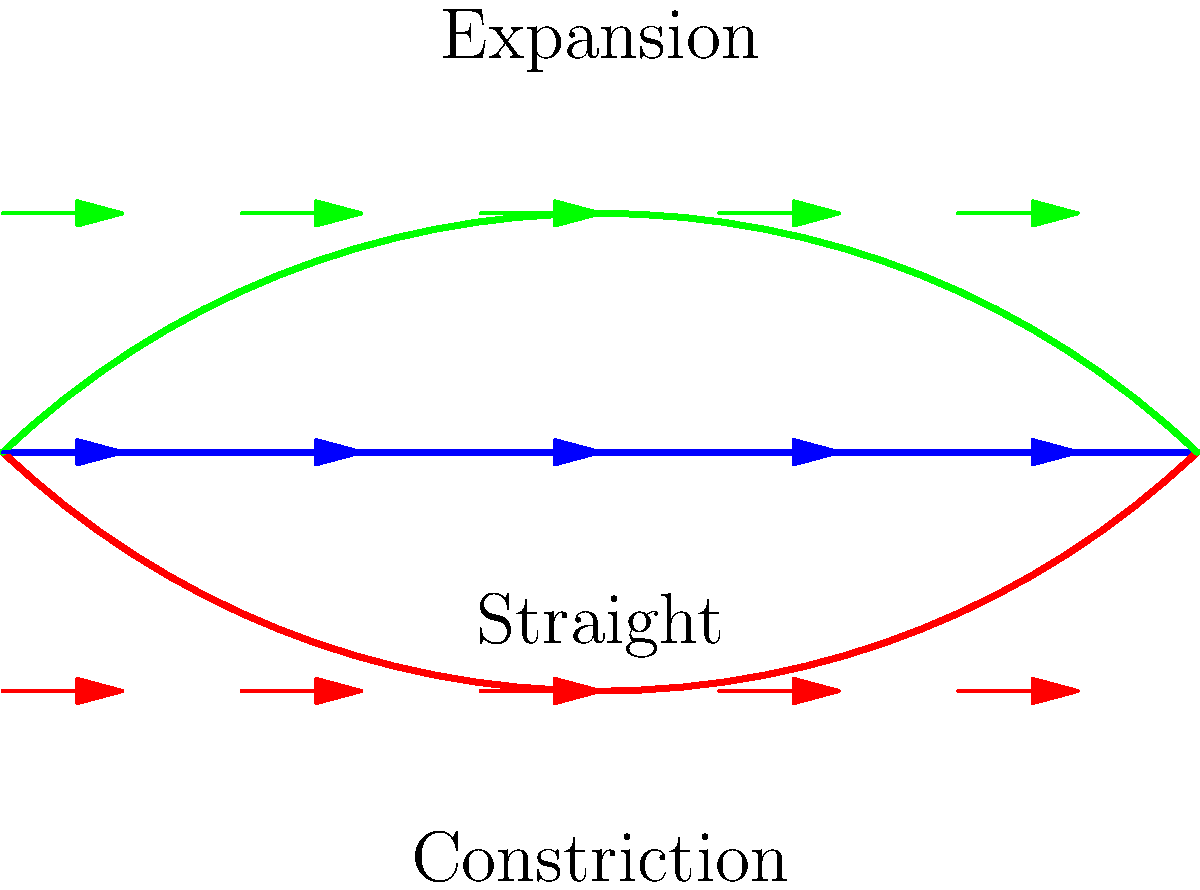As an information architect, you're tasked with visualizing fluid flow patterns through different pipe geometries. Based on the diagram, which pipe geometry would likely result in the highest fluid velocity at the center of the pipe, and why? To answer this question, we need to analyze the fluid flow patterns in each pipe geometry:

1. Straight pipe:
   - Fluid velocity is constant throughout the pipe.
   - No change in cross-sectional area.

2. Constriction pipe:
   - Cross-sectional area decreases in the middle.
   - According to the continuity equation: $Q = A_1v_1 = A_2v_2$
   - As area (A) decreases, velocity (v) must increase to maintain constant flow rate (Q).

3. Expansion pipe:
   - Cross-sectional area increases in the middle.
   - Using the continuity equation again: $Q = A_1v_1 = A_2v_2$
   - As area (A) increases, velocity (v) must decrease to maintain constant flow rate (Q).

The constriction pipe will have the highest fluid velocity at its center because:
   - It has the smallest cross-sectional area at the center.
   - The fluid must speed up to maintain the same flow rate through the smaller area.
   - This is described by the Venturi effect, where fluid velocity increases as it passes through a constriction.

The relationship between velocity and area in incompressible flow is given by:

$$ v_2 = v_1 \frac{A_1}{A_2} $$

Where $v_1$ and $A_1$ are the initial velocity and area, and $v_2$ and $A_2$ are the velocity and area at the constriction.
Answer: Constriction pipe due to the Venturi effect 